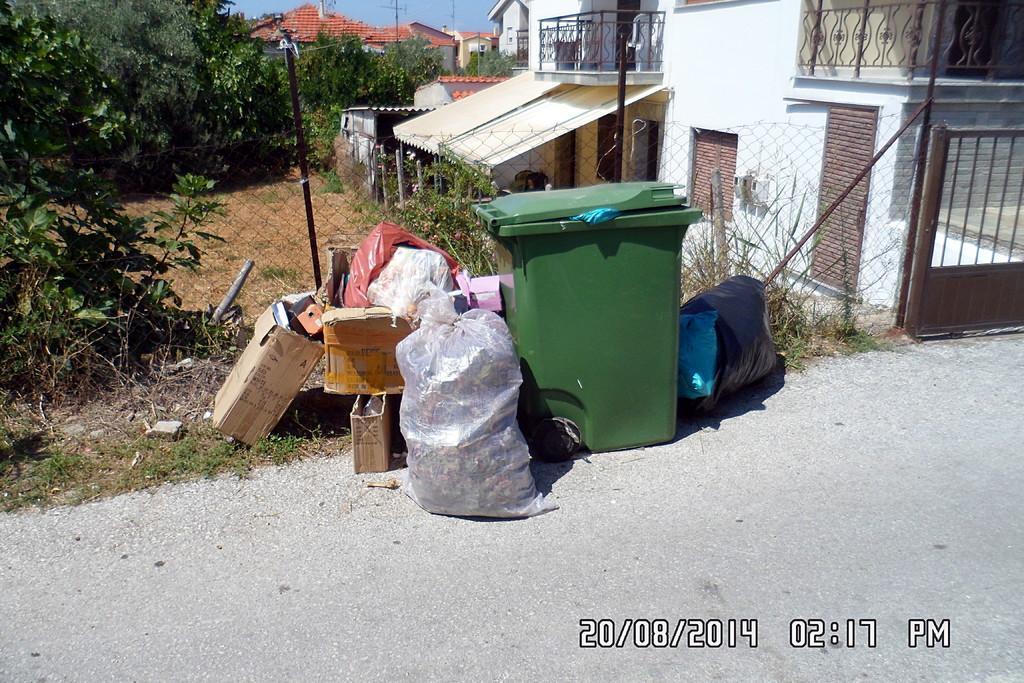Describe this image in one or two sentences. In this picture we can see a dustbin, cardboard boxes, some plastic bags in the front, on the left side there are trees, in the background we can see buildings, there is a pole in the middle, we can see the sky at the top of the picture, at the bottom there is some grass and stones, at the right bottom we can see time, date, month and year. 